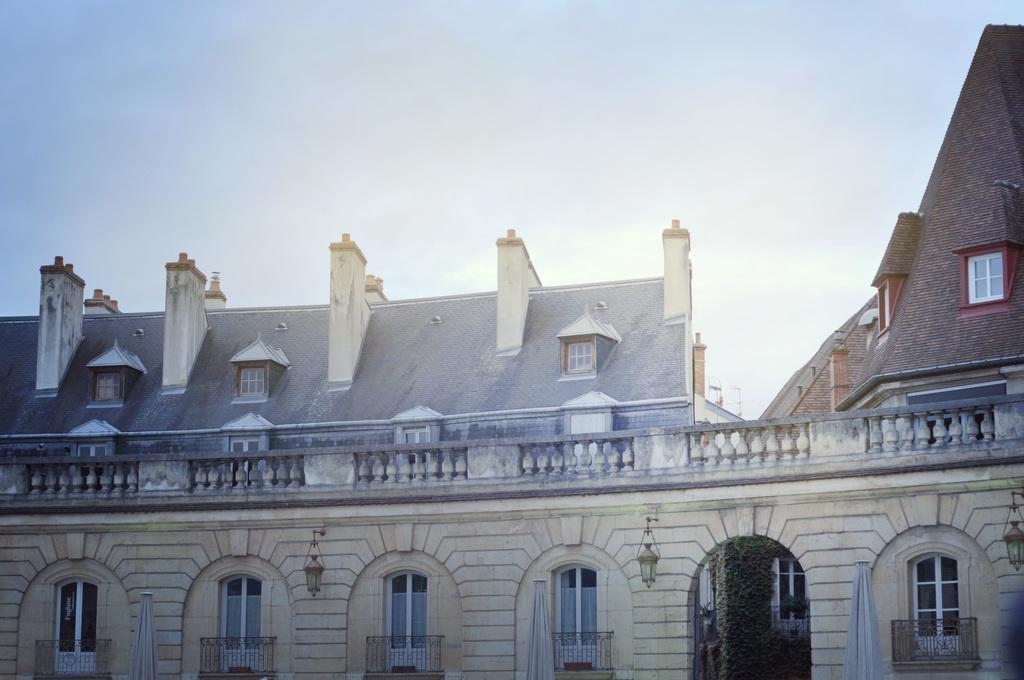What type of structure is in the image? There is a building in the image. What feature can be seen on the building? The building has windows. What can be seen illuminated in the image? There are lights visible in the image. What architectural element is present in the image? Iron grilles are present in the image. What type of vegetation is visible in the image? Plants are visible in the image. What is visible in the background of the image? The sky is visible in the background of the image. What letter is written on the soup in the image? There is no soup present in the image, and therefore no letter can be written on it. 